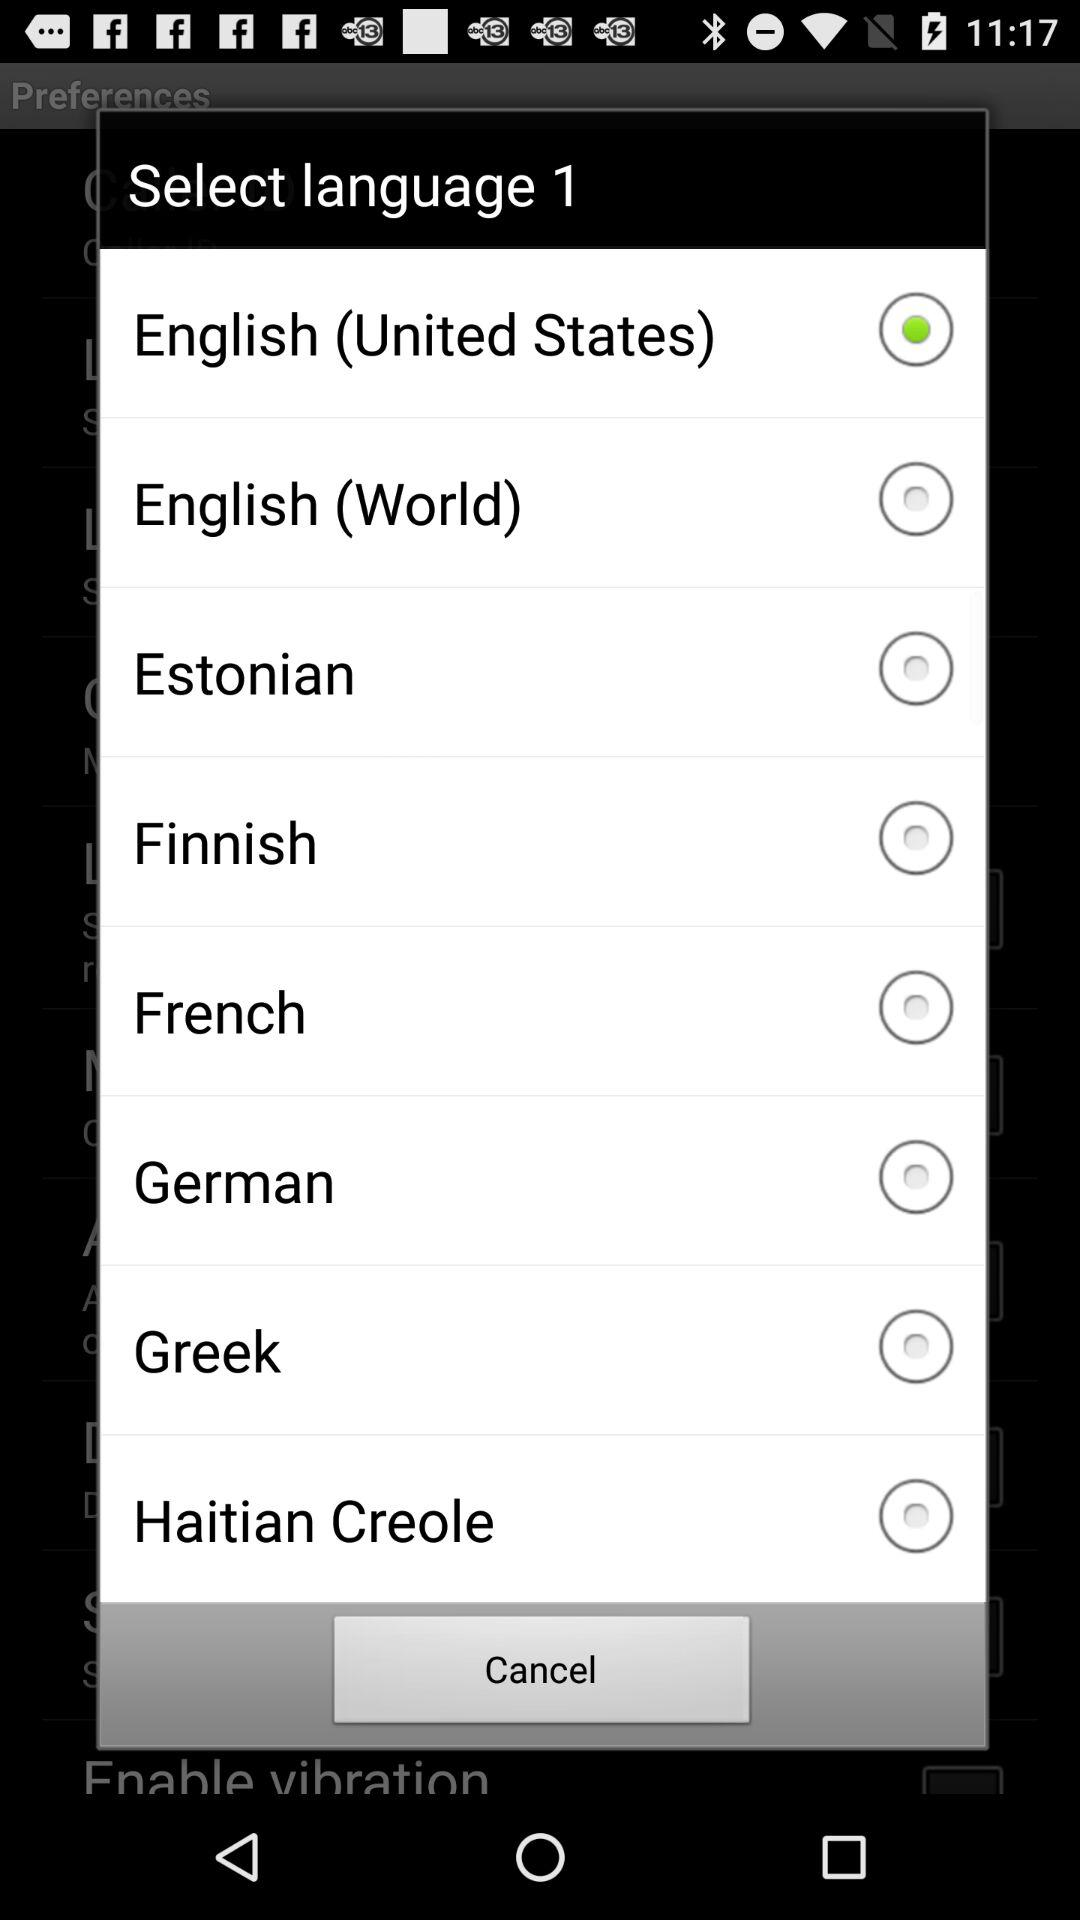How many languages are available to select?
Answer the question using a single word or phrase. 8 